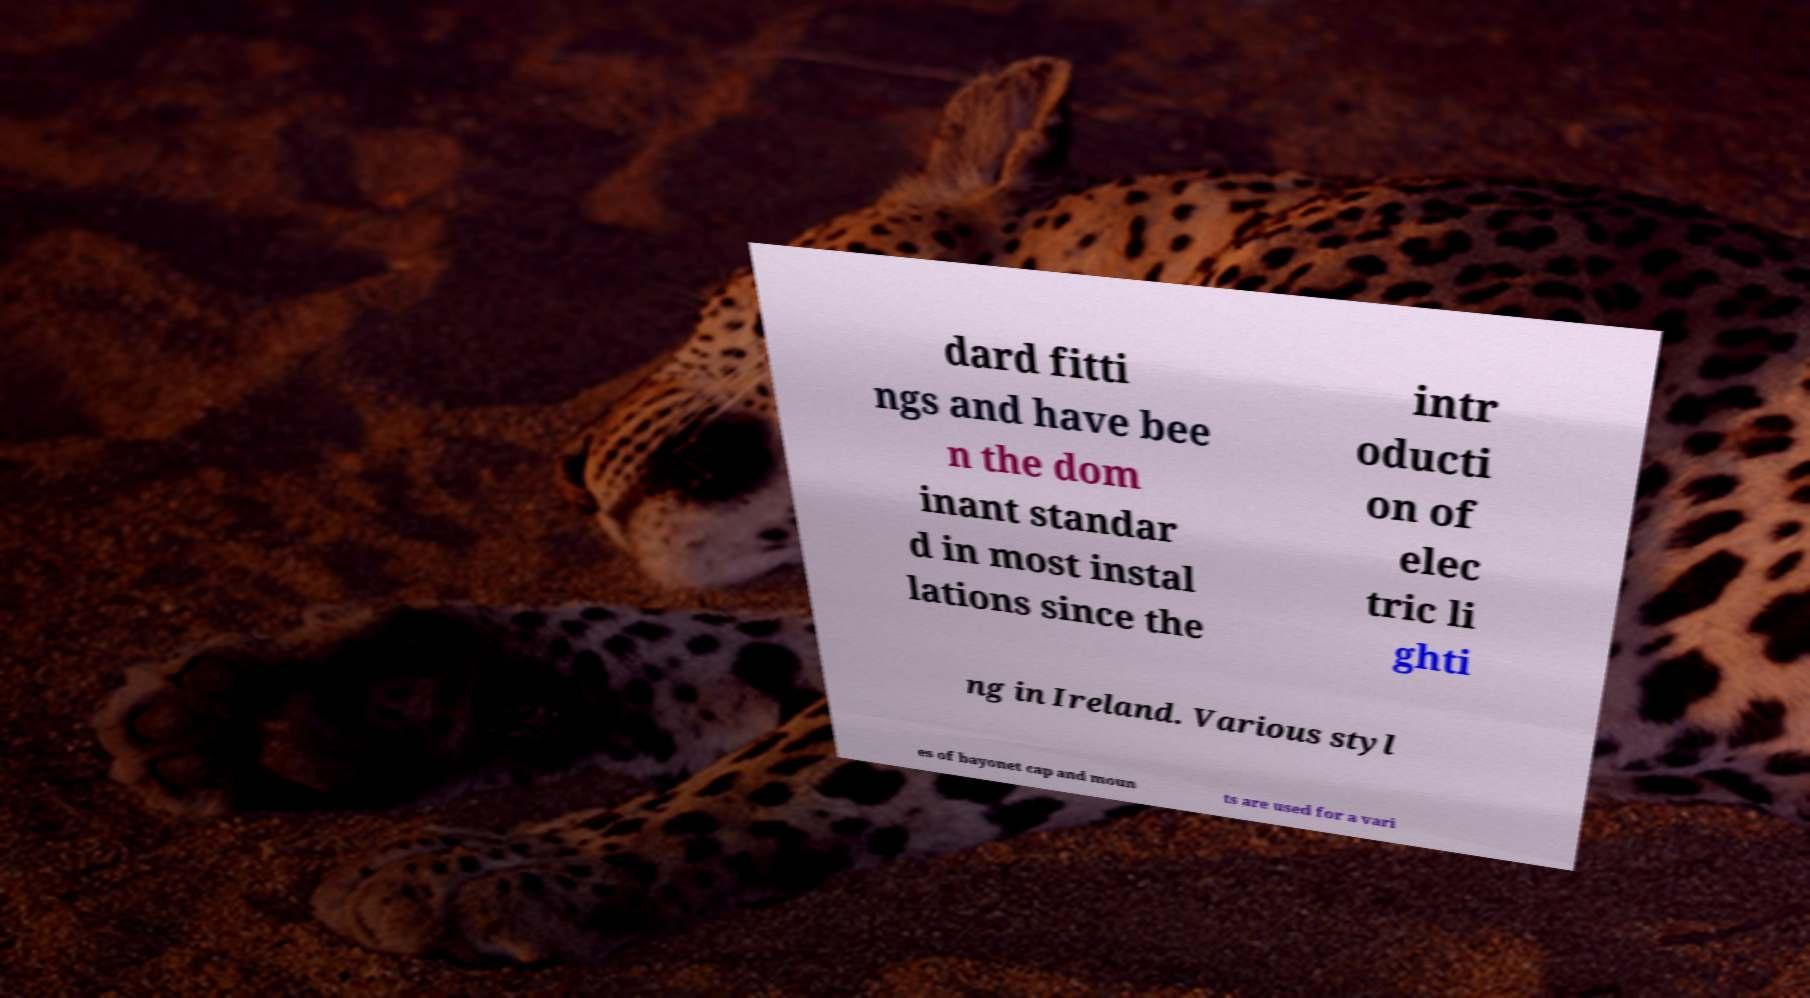Can you accurately transcribe the text from the provided image for me? dard fitti ngs and have bee n the dom inant standar d in most instal lations since the intr oducti on of elec tric li ghti ng in Ireland. Various styl es of bayonet cap and moun ts are used for a vari 